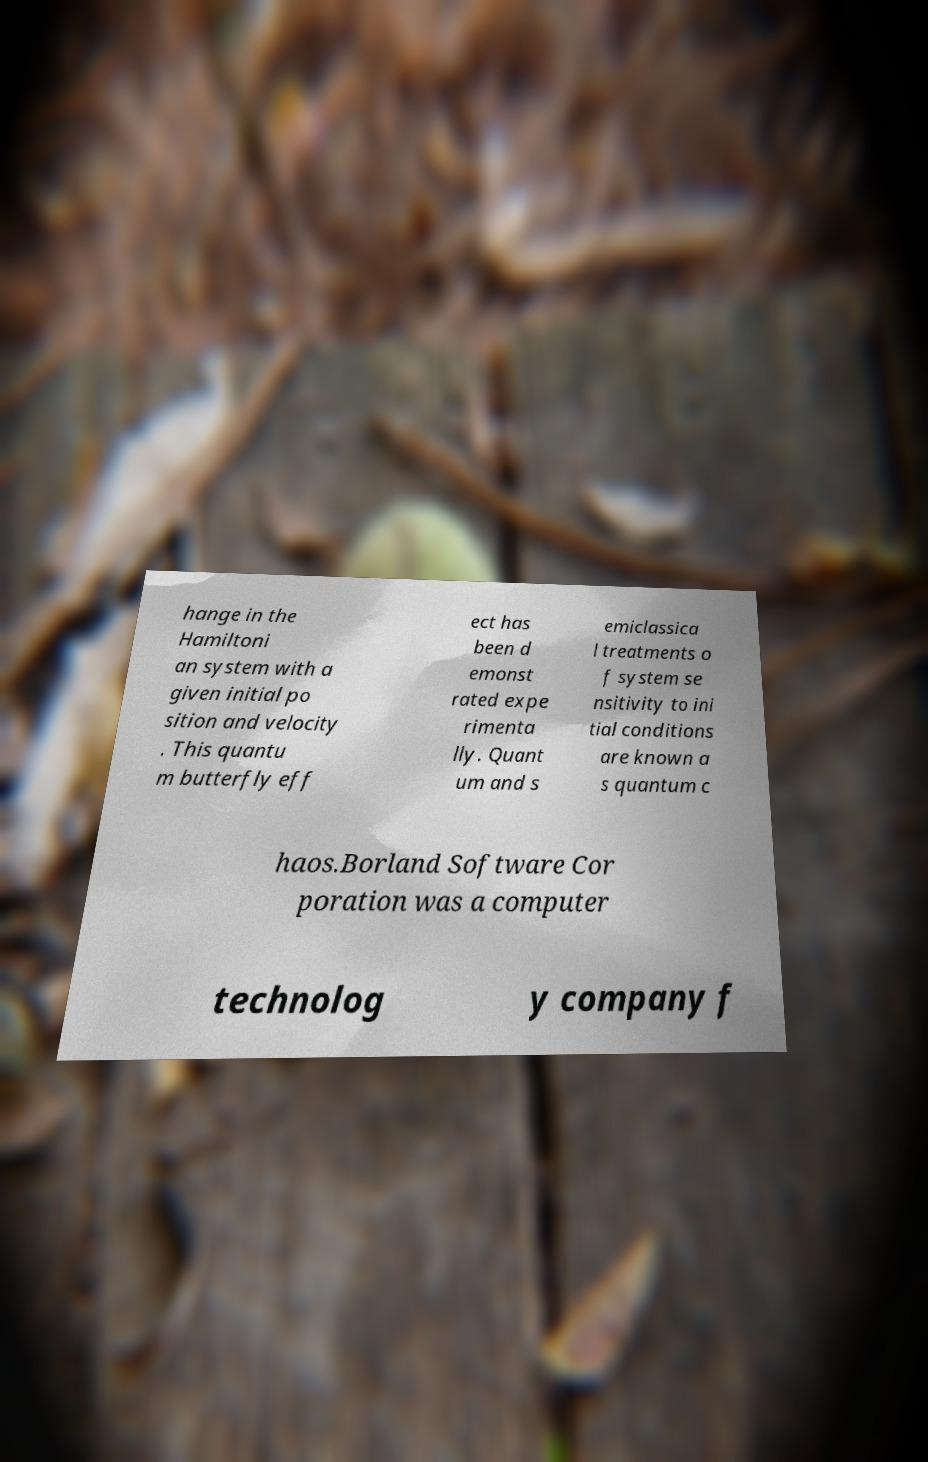I need the written content from this picture converted into text. Can you do that? hange in the Hamiltoni an system with a given initial po sition and velocity . This quantu m butterfly eff ect has been d emonst rated expe rimenta lly. Quant um and s emiclassica l treatments o f system se nsitivity to ini tial conditions are known a s quantum c haos.Borland Software Cor poration was a computer technolog y company f 